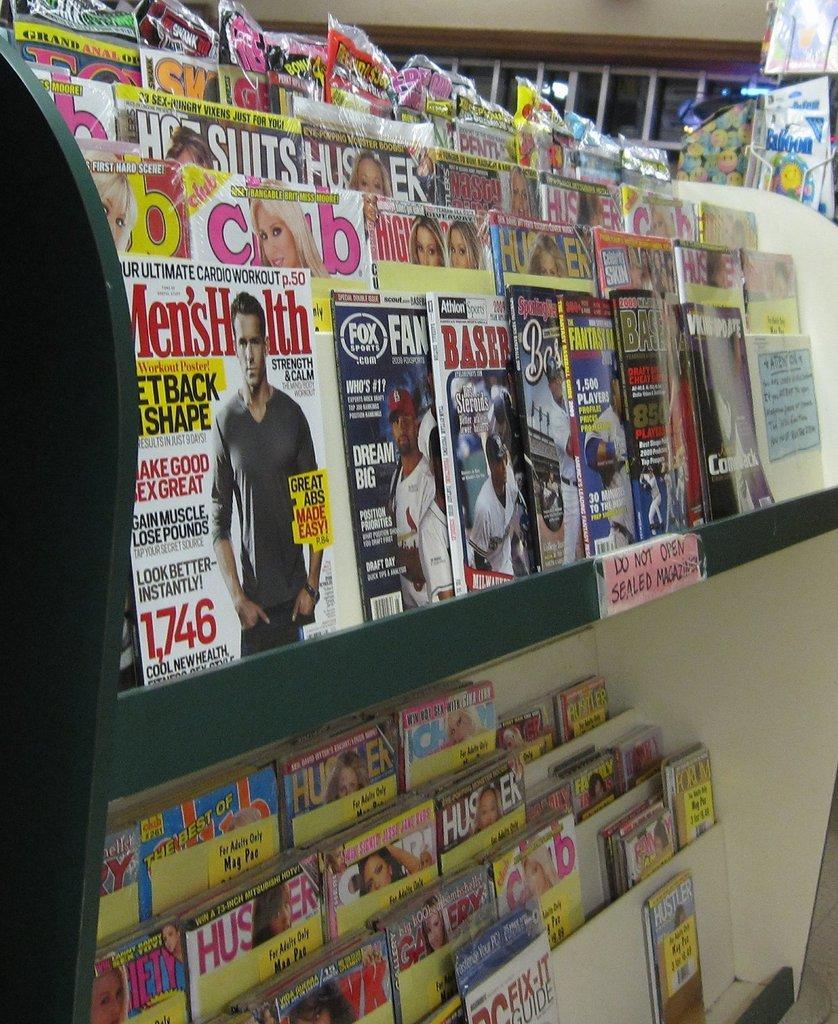How would you summarize this image in a sentence or two? In this picture I can see some Maxine's kept in the shelves. 